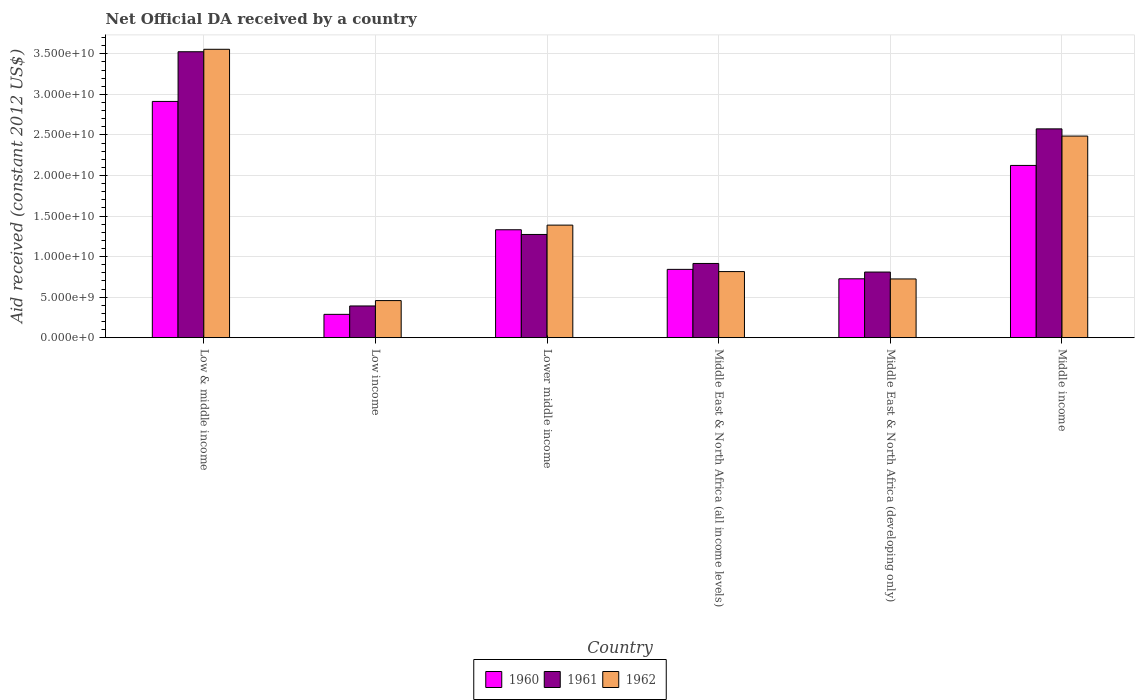What is the label of the 3rd group of bars from the left?
Provide a succinct answer. Lower middle income. What is the net official development assistance aid received in 1961 in Middle East & North Africa (developing only)?
Your answer should be very brief. 8.09e+09. Across all countries, what is the maximum net official development assistance aid received in 1960?
Give a very brief answer. 2.91e+1. Across all countries, what is the minimum net official development assistance aid received in 1962?
Give a very brief answer. 4.57e+09. What is the total net official development assistance aid received in 1962 in the graph?
Keep it short and to the point. 9.43e+1. What is the difference between the net official development assistance aid received in 1961 in Lower middle income and that in Middle income?
Make the answer very short. -1.30e+1. What is the difference between the net official development assistance aid received in 1961 in Middle income and the net official development assistance aid received in 1962 in Low & middle income?
Offer a terse response. -9.81e+09. What is the average net official development assistance aid received in 1961 per country?
Your response must be concise. 1.58e+1. What is the difference between the net official development assistance aid received of/in 1961 and net official development assistance aid received of/in 1960 in Low & middle income?
Ensure brevity in your answer.  6.13e+09. In how many countries, is the net official development assistance aid received in 1960 greater than 8000000000 US$?
Provide a succinct answer. 4. What is the ratio of the net official development assistance aid received in 1960 in Middle East & North Africa (all income levels) to that in Middle income?
Your answer should be very brief. 0.4. Is the net official development assistance aid received in 1961 in Lower middle income less than that in Middle East & North Africa (developing only)?
Offer a very short reply. No. What is the difference between the highest and the second highest net official development assistance aid received in 1961?
Your answer should be very brief. 2.25e+1. What is the difference between the highest and the lowest net official development assistance aid received in 1960?
Your answer should be compact. 2.63e+1. What does the 1st bar from the left in Lower middle income represents?
Ensure brevity in your answer.  1960. What does the 2nd bar from the right in Middle East & North Africa (all income levels) represents?
Offer a terse response. 1961. How many bars are there?
Offer a terse response. 18. What is the difference between two consecutive major ticks on the Y-axis?
Your response must be concise. 5.00e+09. Does the graph contain any zero values?
Give a very brief answer. No. How are the legend labels stacked?
Ensure brevity in your answer.  Horizontal. What is the title of the graph?
Keep it short and to the point. Net Official DA received by a country. What is the label or title of the X-axis?
Offer a very short reply. Country. What is the label or title of the Y-axis?
Keep it short and to the point. Aid received (constant 2012 US$). What is the Aid received (constant 2012 US$) in 1960 in Low & middle income?
Offer a terse response. 2.91e+1. What is the Aid received (constant 2012 US$) in 1961 in Low & middle income?
Provide a succinct answer. 3.53e+1. What is the Aid received (constant 2012 US$) in 1962 in Low & middle income?
Your answer should be very brief. 3.56e+1. What is the Aid received (constant 2012 US$) of 1960 in Low income?
Offer a very short reply. 2.87e+09. What is the Aid received (constant 2012 US$) in 1961 in Low income?
Your answer should be compact. 3.91e+09. What is the Aid received (constant 2012 US$) of 1962 in Low income?
Provide a short and direct response. 4.57e+09. What is the Aid received (constant 2012 US$) in 1960 in Lower middle income?
Provide a succinct answer. 1.33e+1. What is the Aid received (constant 2012 US$) in 1961 in Lower middle income?
Give a very brief answer. 1.27e+1. What is the Aid received (constant 2012 US$) in 1962 in Lower middle income?
Offer a terse response. 1.39e+1. What is the Aid received (constant 2012 US$) in 1960 in Middle East & North Africa (all income levels)?
Offer a terse response. 8.42e+09. What is the Aid received (constant 2012 US$) of 1961 in Middle East & North Africa (all income levels)?
Your response must be concise. 9.15e+09. What is the Aid received (constant 2012 US$) in 1962 in Middle East & North Africa (all income levels)?
Your response must be concise. 8.15e+09. What is the Aid received (constant 2012 US$) in 1960 in Middle East & North Africa (developing only)?
Your answer should be very brief. 7.26e+09. What is the Aid received (constant 2012 US$) of 1961 in Middle East & North Africa (developing only)?
Keep it short and to the point. 8.09e+09. What is the Aid received (constant 2012 US$) of 1962 in Middle East & North Africa (developing only)?
Your response must be concise. 7.24e+09. What is the Aid received (constant 2012 US$) in 1960 in Middle income?
Provide a short and direct response. 2.12e+1. What is the Aid received (constant 2012 US$) of 1961 in Middle income?
Provide a succinct answer. 2.58e+1. What is the Aid received (constant 2012 US$) of 1962 in Middle income?
Your response must be concise. 2.49e+1. Across all countries, what is the maximum Aid received (constant 2012 US$) of 1960?
Ensure brevity in your answer.  2.91e+1. Across all countries, what is the maximum Aid received (constant 2012 US$) of 1961?
Give a very brief answer. 3.53e+1. Across all countries, what is the maximum Aid received (constant 2012 US$) of 1962?
Provide a short and direct response. 3.56e+1. Across all countries, what is the minimum Aid received (constant 2012 US$) of 1960?
Give a very brief answer. 2.87e+09. Across all countries, what is the minimum Aid received (constant 2012 US$) of 1961?
Provide a short and direct response. 3.91e+09. Across all countries, what is the minimum Aid received (constant 2012 US$) in 1962?
Keep it short and to the point. 4.57e+09. What is the total Aid received (constant 2012 US$) in 1960 in the graph?
Offer a terse response. 8.22e+1. What is the total Aid received (constant 2012 US$) of 1961 in the graph?
Give a very brief answer. 9.49e+1. What is the total Aid received (constant 2012 US$) of 1962 in the graph?
Give a very brief answer. 9.43e+1. What is the difference between the Aid received (constant 2012 US$) of 1960 in Low & middle income and that in Low income?
Keep it short and to the point. 2.63e+1. What is the difference between the Aid received (constant 2012 US$) in 1961 in Low & middle income and that in Low income?
Give a very brief answer. 3.14e+1. What is the difference between the Aid received (constant 2012 US$) in 1962 in Low & middle income and that in Low income?
Keep it short and to the point. 3.10e+1. What is the difference between the Aid received (constant 2012 US$) of 1960 in Low & middle income and that in Lower middle income?
Your response must be concise. 1.58e+1. What is the difference between the Aid received (constant 2012 US$) in 1961 in Low & middle income and that in Lower middle income?
Give a very brief answer. 2.25e+1. What is the difference between the Aid received (constant 2012 US$) of 1962 in Low & middle income and that in Lower middle income?
Provide a short and direct response. 2.17e+1. What is the difference between the Aid received (constant 2012 US$) in 1960 in Low & middle income and that in Middle East & North Africa (all income levels)?
Provide a succinct answer. 2.07e+1. What is the difference between the Aid received (constant 2012 US$) of 1961 in Low & middle income and that in Middle East & North Africa (all income levels)?
Your answer should be very brief. 2.61e+1. What is the difference between the Aid received (constant 2012 US$) of 1962 in Low & middle income and that in Middle East & North Africa (all income levels)?
Your answer should be compact. 2.74e+1. What is the difference between the Aid received (constant 2012 US$) of 1960 in Low & middle income and that in Middle East & North Africa (developing only)?
Offer a very short reply. 2.19e+1. What is the difference between the Aid received (constant 2012 US$) of 1961 in Low & middle income and that in Middle East & North Africa (developing only)?
Keep it short and to the point. 2.72e+1. What is the difference between the Aid received (constant 2012 US$) in 1962 in Low & middle income and that in Middle East & North Africa (developing only)?
Offer a terse response. 2.83e+1. What is the difference between the Aid received (constant 2012 US$) of 1960 in Low & middle income and that in Middle income?
Provide a short and direct response. 7.89e+09. What is the difference between the Aid received (constant 2012 US$) of 1961 in Low & middle income and that in Middle income?
Offer a very short reply. 9.51e+09. What is the difference between the Aid received (constant 2012 US$) of 1962 in Low & middle income and that in Middle income?
Provide a succinct answer. 1.07e+1. What is the difference between the Aid received (constant 2012 US$) in 1960 in Low income and that in Lower middle income?
Give a very brief answer. -1.04e+1. What is the difference between the Aid received (constant 2012 US$) of 1961 in Low income and that in Lower middle income?
Your answer should be very brief. -8.82e+09. What is the difference between the Aid received (constant 2012 US$) in 1962 in Low income and that in Lower middle income?
Keep it short and to the point. -9.31e+09. What is the difference between the Aid received (constant 2012 US$) of 1960 in Low income and that in Middle East & North Africa (all income levels)?
Give a very brief answer. -5.55e+09. What is the difference between the Aid received (constant 2012 US$) of 1961 in Low income and that in Middle East & North Africa (all income levels)?
Keep it short and to the point. -5.24e+09. What is the difference between the Aid received (constant 2012 US$) of 1962 in Low income and that in Middle East & North Africa (all income levels)?
Give a very brief answer. -3.58e+09. What is the difference between the Aid received (constant 2012 US$) of 1960 in Low income and that in Middle East & North Africa (developing only)?
Ensure brevity in your answer.  -4.39e+09. What is the difference between the Aid received (constant 2012 US$) in 1961 in Low income and that in Middle East & North Africa (developing only)?
Provide a succinct answer. -4.18e+09. What is the difference between the Aid received (constant 2012 US$) of 1962 in Low income and that in Middle East & North Africa (developing only)?
Your answer should be very brief. -2.67e+09. What is the difference between the Aid received (constant 2012 US$) in 1960 in Low income and that in Middle income?
Give a very brief answer. -1.84e+1. What is the difference between the Aid received (constant 2012 US$) in 1961 in Low income and that in Middle income?
Provide a short and direct response. -2.18e+1. What is the difference between the Aid received (constant 2012 US$) in 1962 in Low income and that in Middle income?
Give a very brief answer. -2.03e+1. What is the difference between the Aid received (constant 2012 US$) in 1960 in Lower middle income and that in Middle East & North Africa (all income levels)?
Your answer should be compact. 4.89e+09. What is the difference between the Aid received (constant 2012 US$) of 1961 in Lower middle income and that in Middle East & North Africa (all income levels)?
Your answer should be very brief. 3.58e+09. What is the difference between the Aid received (constant 2012 US$) of 1962 in Lower middle income and that in Middle East & North Africa (all income levels)?
Keep it short and to the point. 5.73e+09. What is the difference between the Aid received (constant 2012 US$) in 1960 in Lower middle income and that in Middle East & North Africa (developing only)?
Your response must be concise. 6.05e+09. What is the difference between the Aid received (constant 2012 US$) in 1961 in Lower middle income and that in Middle East & North Africa (developing only)?
Give a very brief answer. 4.64e+09. What is the difference between the Aid received (constant 2012 US$) in 1962 in Lower middle income and that in Middle East & North Africa (developing only)?
Offer a very short reply. 6.64e+09. What is the difference between the Aid received (constant 2012 US$) in 1960 in Lower middle income and that in Middle income?
Your answer should be compact. -7.93e+09. What is the difference between the Aid received (constant 2012 US$) in 1961 in Lower middle income and that in Middle income?
Give a very brief answer. -1.30e+1. What is the difference between the Aid received (constant 2012 US$) in 1962 in Lower middle income and that in Middle income?
Your answer should be compact. -1.10e+1. What is the difference between the Aid received (constant 2012 US$) in 1960 in Middle East & North Africa (all income levels) and that in Middle East & North Africa (developing only)?
Keep it short and to the point. 1.16e+09. What is the difference between the Aid received (constant 2012 US$) in 1961 in Middle East & North Africa (all income levels) and that in Middle East & North Africa (developing only)?
Keep it short and to the point. 1.06e+09. What is the difference between the Aid received (constant 2012 US$) of 1962 in Middle East & North Africa (all income levels) and that in Middle East & North Africa (developing only)?
Offer a very short reply. 9.07e+08. What is the difference between the Aid received (constant 2012 US$) of 1960 in Middle East & North Africa (all income levels) and that in Middle income?
Keep it short and to the point. -1.28e+1. What is the difference between the Aid received (constant 2012 US$) of 1961 in Middle East & North Africa (all income levels) and that in Middle income?
Ensure brevity in your answer.  -1.66e+1. What is the difference between the Aid received (constant 2012 US$) of 1962 in Middle East & North Africa (all income levels) and that in Middle income?
Keep it short and to the point. -1.67e+1. What is the difference between the Aid received (constant 2012 US$) in 1960 in Middle East & North Africa (developing only) and that in Middle income?
Keep it short and to the point. -1.40e+1. What is the difference between the Aid received (constant 2012 US$) of 1961 in Middle East & North Africa (developing only) and that in Middle income?
Your answer should be compact. -1.77e+1. What is the difference between the Aid received (constant 2012 US$) in 1962 in Middle East & North Africa (developing only) and that in Middle income?
Keep it short and to the point. -1.76e+1. What is the difference between the Aid received (constant 2012 US$) in 1960 in Low & middle income and the Aid received (constant 2012 US$) in 1961 in Low income?
Give a very brief answer. 2.52e+1. What is the difference between the Aid received (constant 2012 US$) of 1960 in Low & middle income and the Aid received (constant 2012 US$) of 1962 in Low income?
Give a very brief answer. 2.46e+1. What is the difference between the Aid received (constant 2012 US$) in 1961 in Low & middle income and the Aid received (constant 2012 US$) in 1962 in Low income?
Offer a very short reply. 3.07e+1. What is the difference between the Aid received (constant 2012 US$) of 1960 in Low & middle income and the Aid received (constant 2012 US$) of 1961 in Lower middle income?
Ensure brevity in your answer.  1.64e+1. What is the difference between the Aid received (constant 2012 US$) of 1960 in Low & middle income and the Aid received (constant 2012 US$) of 1962 in Lower middle income?
Give a very brief answer. 1.53e+1. What is the difference between the Aid received (constant 2012 US$) in 1961 in Low & middle income and the Aid received (constant 2012 US$) in 1962 in Lower middle income?
Provide a short and direct response. 2.14e+1. What is the difference between the Aid received (constant 2012 US$) of 1960 in Low & middle income and the Aid received (constant 2012 US$) of 1961 in Middle East & North Africa (all income levels)?
Your response must be concise. 2.00e+1. What is the difference between the Aid received (constant 2012 US$) in 1960 in Low & middle income and the Aid received (constant 2012 US$) in 1962 in Middle East & North Africa (all income levels)?
Your answer should be very brief. 2.10e+1. What is the difference between the Aid received (constant 2012 US$) of 1961 in Low & middle income and the Aid received (constant 2012 US$) of 1962 in Middle East & North Africa (all income levels)?
Make the answer very short. 2.71e+1. What is the difference between the Aid received (constant 2012 US$) in 1960 in Low & middle income and the Aid received (constant 2012 US$) in 1961 in Middle East & North Africa (developing only)?
Ensure brevity in your answer.  2.10e+1. What is the difference between the Aid received (constant 2012 US$) of 1960 in Low & middle income and the Aid received (constant 2012 US$) of 1962 in Middle East & North Africa (developing only)?
Your answer should be very brief. 2.19e+1. What is the difference between the Aid received (constant 2012 US$) in 1961 in Low & middle income and the Aid received (constant 2012 US$) in 1962 in Middle East & North Africa (developing only)?
Give a very brief answer. 2.80e+1. What is the difference between the Aid received (constant 2012 US$) of 1960 in Low & middle income and the Aid received (constant 2012 US$) of 1961 in Middle income?
Keep it short and to the point. 3.38e+09. What is the difference between the Aid received (constant 2012 US$) of 1960 in Low & middle income and the Aid received (constant 2012 US$) of 1962 in Middle income?
Make the answer very short. 4.27e+09. What is the difference between the Aid received (constant 2012 US$) of 1961 in Low & middle income and the Aid received (constant 2012 US$) of 1962 in Middle income?
Ensure brevity in your answer.  1.04e+1. What is the difference between the Aid received (constant 2012 US$) of 1960 in Low income and the Aid received (constant 2012 US$) of 1961 in Lower middle income?
Make the answer very short. -9.85e+09. What is the difference between the Aid received (constant 2012 US$) of 1960 in Low income and the Aid received (constant 2012 US$) of 1962 in Lower middle income?
Ensure brevity in your answer.  -1.10e+1. What is the difference between the Aid received (constant 2012 US$) in 1961 in Low income and the Aid received (constant 2012 US$) in 1962 in Lower middle income?
Your answer should be compact. -9.97e+09. What is the difference between the Aid received (constant 2012 US$) of 1960 in Low income and the Aid received (constant 2012 US$) of 1961 in Middle East & North Africa (all income levels)?
Keep it short and to the point. -6.28e+09. What is the difference between the Aid received (constant 2012 US$) in 1960 in Low income and the Aid received (constant 2012 US$) in 1962 in Middle East & North Africa (all income levels)?
Provide a succinct answer. -5.27e+09. What is the difference between the Aid received (constant 2012 US$) in 1961 in Low income and the Aid received (constant 2012 US$) in 1962 in Middle East & North Africa (all income levels)?
Ensure brevity in your answer.  -4.24e+09. What is the difference between the Aid received (constant 2012 US$) of 1960 in Low income and the Aid received (constant 2012 US$) of 1961 in Middle East & North Africa (developing only)?
Your answer should be compact. -5.22e+09. What is the difference between the Aid received (constant 2012 US$) of 1960 in Low income and the Aid received (constant 2012 US$) of 1962 in Middle East & North Africa (developing only)?
Your response must be concise. -4.37e+09. What is the difference between the Aid received (constant 2012 US$) in 1961 in Low income and the Aid received (constant 2012 US$) in 1962 in Middle East & North Africa (developing only)?
Make the answer very short. -3.33e+09. What is the difference between the Aid received (constant 2012 US$) of 1960 in Low income and the Aid received (constant 2012 US$) of 1961 in Middle income?
Make the answer very short. -2.29e+1. What is the difference between the Aid received (constant 2012 US$) in 1960 in Low income and the Aid received (constant 2012 US$) in 1962 in Middle income?
Provide a succinct answer. -2.20e+1. What is the difference between the Aid received (constant 2012 US$) of 1961 in Low income and the Aid received (constant 2012 US$) of 1962 in Middle income?
Offer a very short reply. -2.10e+1. What is the difference between the Aid received (constant 2012 US$) in 1960 in Lower middle income and the Aid received (constant 2012 US$) in 1961 in Middle East & North Africa (all income levels)?
Provide a succinct answer. 4.16e+09. What is the difference between the Aid received (constant 2012 US$) in 1960 in Lower middle income and the Aid received (constant 2012 US$) in 1962 in Middle East & North Africa (all income levels)?
Provide a succinct answer. 5.16e+09. What is the difference between the Aid received (constant 2012 US$) of 1961 in Lower middle income and the Aid received (constant 2012 US$) of 1962 in Middle East & North Africa (all income levels)?
Your answer should be compact. 4.58e+09. What is the difference between the Aid received (constant 2012 US$) in 1960 in Lower middle income and the Aid received (constant 2012 US$) in 1961 in Middle East & North Africa (developing only)?
Offer a very short reply. 5.22e+09. What is the difference between the Aid received (constant 2012 US$) of 1960 in Lower middle income and the Aid received (constant 2012 US$) of 1962 in Middle East & North Africa (developing only)?
Offer a terse response. 6.07e+09. What is the difference between the Aid received (constant 2012 US$) in 1961 in Lower middle income and the Aid received (constant 2012 US$) in 1962 in Middle East & North Africa (developing only)?
Offer a terse response. 5.49e+09. What is the difference between the Aid received (constant 2012 US$) of 1960 in Lower middle income and the Aid received (constant 2012 US$) of 1961 in Middle income?
Your response must be concise. -1.24e+1. What is the difference between the Aid received (constant 2012 US$) in 1960 in Lower middle income and the Aid received (constant 2012 US$) in 1962 in Middle income?
Provide a succinct answer. -1.16e+1. What is the difference between the Aid received (constant 2012 US$) of 1961 in Lower middle income and the Aid received (constant 2012 US$) of 1962 in Middle income?
Your answer should be compact. -1.21e+1. What is the difference between the Aid received (constant 2012 US$) of 1960 in Middle East & North Africa (all income levels) and the Aid received (constant 2012 US$) of 1961 in Middle East & North Africa (developing only)?
Your answer should be compact. 3.30e+08. What is the difference between the Aid received (constant 2012 US$) in 1960 in Middle East & North Africa (all income levels) and the Aid received (constant 2012 US$) in 1962 in Middle East & North Africa (developing only)?
Give a very brief answer. 1.18e+09. What is the difference between the Aid received (constant 2012 US$) in 1961 in Middle East & North Africa (all income levels) and the Aid received (constant 2012 US$) in 1962 in Middle East & North Africa (developing only)?
Ensure brevity in your answer.  1.91e+09. What is the difference between the Aid received (constant 2012 US$) of 1960 in Middle East & North Africa (all income levels) and the Aid received (constant 2012 US$) of 1961 in Middle income?
Offer a terse response. -1.73e+1. What is the difference between the Aid received (constant 2012 US$) of 1960 in Middle East & North Africa (all income levels) and the Aid received (constant 2012 US$) of 1962 in Middle income?
Your answer should be very brief. -1.64e+1. What is the difference between the Aid received (constant 2012 US$) in 1961 in Middle East & North Africa (all income levels) and the Aid received (constant 2012 US$) in 1962 in Middle income?
Ensure brevity in your answer.  -1.57e+1. What is the difference between the Aid received (constant 2012 US$) in 1960 in Middle East & North Africa (developing only) and the Aid received (constant 2012 US$) in 1961 in Middle income?
Make the answer very short. -1.85e+1. What is the difference between the Aid received (constant 2012 US$) in 1960 in Middle East & North Africa (developing only) and the Aid received (constant 2012 US$) in 1962 in Middle income?
Give a very brief answer. -1.76e+1. What is the difference between the Aid received (constant 2012 US$) in 1961 in Middle East & North Africa (developing only) and the Aid received (constant 2012 US$) in 1962 in Middle income?
Your response must be concise. -1.68e+1. What is the average Aid received (constant 2012 US$) in 1960 per country?
Provide a short and direct response. 1.37e+1. What is the average Aid received (constant 2012 US$) of 1961 per country?
Keep it short and to the point. 1.58e+1. What is the average Aid received (constant 2012 US$) in 1962 per country?
Ensure brevity in your answer.  1.57e+1. What is the difference between the Aid received (constant 2012 US$) of 1960 and Aid received (constant 2012 US$) of 1961 in Low & middle income?
Your answer should be very brief. -6.13e+09. What is the difference between the Aid received (constant 2012 US$) in 1960 and Aid received (constant 2012 US$) in 1962 in Low & middle income?
Ensure brevity in your answer.  -6.43e+09. What is the difference between the Aid received (constant 2012 US$) in 1961 and Aid received (constant 2012 US$) in 1962 in Low & middle income?
Give a very brief answer. -3.02e+08. What is the difference between the Aid received (constant 2012 US$) of 1960 and Aid received (constant 2012 US$) of 1961 in Low income?
Your answer should be very brief. -1.04e+09. What is the difference between the Aid received (constant 2012 US$) in 1960 and Aid received (constant 2012 US$) in 1962 in Low income?
Make the answer very short. -1.70e+09. What is the difference between the Aid received (constant 2012 US$) of 1961 and Aid received (constant 2012 US$) of 1962 in Low income?
Give a very brief answer. -6.62e+08. What is the difference between the Aid received (constant 2012 US$) in 1960 and Aid received (constant 2012 US$) in 1961 in Lower middle income?
Offer a terse response. 5.79e+08. What is the difference between the Aid received (constant 2012 US$) of 1960 and Aid received (constant 2012 US$) of 1962 in Lower middle income?
Keep it short and to the point. -5.73e+08. What is the difference between the Aid received (constant 2012 US$) in 1961 and Aid received (constant 2012 US$) in 1962 in Lower middle income?
Your answer should be compact. -1.15e+09. What is the difference between the Aid received (constant 2012 US$) in 1960 and Aid received (constant 2012 US$) in 1961 in Middle East & North Africa (all income levels)?
Keep it short and to the point. -7.30e+08. What is the difference between the Aid received (constant 2012 US$) in 1960 and Aid received (constant 2012 US$) in 1962 in Middle East & North Africa (all income levels)?
Offer a very short reply. 2.73e+08. What is the difference between the Aid received (constant 2012 US$) of 1961 and Aid received (constant 2012 US$) of 1962 in Middle East & North Africa (all income levels)?
Make the answer very short. 1.00e+09. What is the difference between the Aid received (constant 2012 US$) in 1960 and Aid received (constant 2012 US$) in 1961 in Middle East & North Africa (developing only)?
Your answer should be very brief. -8.32e+08. What is the difference between the Aid received (constant 2012 US$) of 1960 and Aid received (constant 2012 US$) of 1962 in Middle East & North Africa (developing only)?
Give a very brief answer. 1.81e+07. What is the difference between the Aid received (constant 2012 US$) of 1961 and Aid received (constant 2012 US$) of 1962 in Middle East & North Africa (developing only)?
Provide a succinct answer. 8.50e+08. What is the difference between the Aid received (constant 2012 US$) of 1960 and Aid received (constant 2012 US$) of 1961 in Middle income?
Provide a short and direct response. -4.51e+09. What is the difference between the Aid received (constant 2012 US$) of 1960 and Aid received (constant 2012 US$) of 1962 in Middle income?
Ensure brevity in your answer.  -3.62e+09. What is the difference between the Aid received (constant 2012 US$) in 1961 and Aid received (constant 2012 US$) in 1962 in Middle income?
Provide a succinct answer. 8.89e+08. What is the ratio of the Aid received (constant 2012 US$) in 1960 in Low & middle income to that in Low income?
Provide a succinct answer. 10.13. What is the ratio of the Aid received (constant 2012 US$) of 1961 in Low & middle income to that in Low income?
Provide a succinct answer. 9.02. What is the ratio of the Aid received (constant 2012 US$) in 1962 in Low & middle income to that in Low income?
Your response must be concise. 7.78. What is the ratio of the Aid received (constant 2012 US$) of 1960 in Low & middle income to that in Lower middle income?
Your response must be concise. 2.19. What is the ratio of the Aid received (constant 2012 US$) in 1961 in Low & middle income to that in Lower middle income?
Make the answer very short. 2.77. What is the ratio of the Aid received (constant 2012 US$) of 1962 in Low & middle income to that in Lower middle income?
Ensure brevity in your answer.  2.56. What is the ratio of the Aid received (constant 2012 US$) of 1960 in Low & middle income to that in Middle East & North Africa (all income levels)?
Ensure brevity in your answer.  3.46. What is the ratio of the Aid received (constant 2012 US$) in 1961 in Low & middle income to that in Middle East & North Africa (all income levels)?
Offer a very short reply. 3.85. What is the ratio of the Aid received (constant 2012 US$) of 1962 in Low & middle income to that in Middle East & North Africa (all income levels)?
Your answer should be very brief. 4.36. What is the ratio of the Aid received (constant 2012 US$) of 1960 in Low & middle income to that in Middle East & North Africa (developing only)?
Make the answer very short. 4.01. What is the ratio of the Aid received (constant 2012 US$) of 1961 in Low & middle income to that in Middle East & North Africa (developing only)?
Provide a short and direct response. 4.36. What is the ratio of the Aid received (constant 2012 US$) of 1962 in Low & middle income to that in Middle East & North Africa (developing only)?
Provide a succinct answer. 4.91. What is the ratio of the Aid received (constant 2012 US$) of 1960 in Low & middle income to that in Middle income?
Offer a very short reply. 1.37. What is the ratio of the Aid received (constant 2012 US$) in 1961 in Low & middle income to that in Middle income?
Your response must be concise. 1.37. What is the ratio of the Aid received (constant 2012 US$) of 1962 in Low & middle income to that in Middle income?
Offer a very short reply. 1.43. What is the ratio of the Aid received (constant 2012 US$) in 1960 in Low income to that in Lower middle income?
Provide a succinct answer. 0.22. What is the ratio of the Aid received (constant 2012 US$) in 1961 in Low income to that in Lower middle income?
Make the answer very short. 0.31. What is the ratio of the Aid received (constant 2012 US$) in 1962 in Low income to that in Lower middle income?
Offer a very short reply. 0.33. What is the ratio of the Aid received (constant 2012 US$) of 1960 in Low income to that in Middle East & North Africa (all income levels)?
Offer a terse response. 0.34. What is the ratio of the Aid received (constant 2012 US$) of 1961 in Low income to that in Middle East & North Africa (all income levels)?
Give a very brief answer. 0.43. What is the ratio of the Aid received (constant 2012 US$) of 1962 in Low income to that in Middle East & North Africa (all income levels)?
Make the answer very short. 0.56. What is the ratio of the Aid received (constant 2012 US$) of 1960 in Low income to that in Middle East & North Africa (developing only)?
Provide a short and direct response. 0.4. What is the ratio of the Aid received (constant 2012 US$) of 1961 in Low income to that in Middle East & North Africa (developing only)?
Provide a short and direct response. 0.48. What is the ratio of the Aid received (constant 2012 US$) of 1962 in Low income to that in Middle East & North Africa (developing only)?
Offer a very short reply. 0.63. What is the ratio of the Aid received (constant 2012 US$) in 1960 in Low income to that in Middle income?
Your response must be concise. 0.14. What is the ratio of the Aid received (constant 2012 US$) of 1961 in Low income to that in Middle income?
Your answer should be very brief. 0.15. What is the ratio of the Aid received (constant 2012 US$) in 1962 in Low income to that in Middle income?
Offer a terse response. 0.18. What is the ratio of the Aid received (constant 2012 US$) of 1960 in Lower middle income to that in Middle East & North Africa (all income levels)?
Keep it short and to the point. 1.58. What is the ratio of the Aid received (constant 2012 US$) in 1961 in Lower middle income to that in Middle East & North Africa (all income levels)?
Your answer should be very brief. 1.39. What is the ratio of the Aid received (constant 2012 US$) of 1962 in Lower middle income to that in Middle East & North Africa (all income levels)?
Your answer should be very brief. 1.7. What is the ratio of the Aid received (constant 2012 US$) of 1960 in Lower middle income to that in Middle East & North Africa (developing only)?
Ensure brevity in your answer.  1.83. What is the ratio of the Aid received (constant 2012 US$) in 1961 in Lower middle income to that in Middle East & North Africa (developing only)?
Provide a short and direct response. 1.57. What is the ratio of the Aid received (constant 2012 US$) in 1962 in Lower middle income to that in Middle East & North Africa (developing only)?
Your response must be concise. 1.92. What is the ratio of the Aid received (constant 2012 US$) of 1960 in Lower middle income to that in Middle income?
Make the answer very short. 0.63. What is the ratio of the Aid received (constant 2012 US$) in 1961 in Lower middle income to that in Middle income?
Provide a short and direct response. 0.49. What is the ratio of the Aid received (constant 2012 US$) of 1962 in Lower middle income to that in Middle income?
Your answer should be compact. 0.56. What is the ratio of the Aid received (constant 2012 US$) in 1960 in Middle East & North Africa (all income levels) to that in Middle East & North Africa (developing only)?
Your answer should be compact. 1.16. What is the ratio of the Aid received (constant 2012 US$) in 1961 in Middle East & North Africa (all income levels) to that in Middle East & North Africa (developing only)?
Offer a very short reply. 1.13. What is the ratio of the Aid received (constant 2012 US$) in 1962 in Middle East & North Africa (all income levels) to that in Middle East & North Africa (developing only)?
Your response must be concise. 1.13. What is the ratio of the Aid received (constant 2012 US$) in 1960 in Middle East & North Africa (all income levels) to that in Middle income?
Your response must be concise. 0.4. What is the ratio of the Aid received (constant 2012 US$) of 1961 in Middle East & North Africa (all income levels) to that in Middle income?
Keep it short and to the point. 0.36. What is the ratio of the Aid received (constant 2012 US$) of 1962 in Middle East & North Africa (all income levels) to that in Middle income?
Make the answer very short. 0.33. What is the ratio of the Aid received (constant 2012 US$) in 1960 in Middle East & North Africa (developing only) to that in Middle income?
Give a very brief answer. 0.34. What is the ratio of the Aid received (constant 2012 US$) in 1961 in Middle East & North Africa (developing only) to that in Middle income?
Provide a succinct answer. 0.31. What is the ratio of the Aid received (constant 2012 US$) in 1962 in Middle East & North Africa (developing only) to that in Middle income?
Your answer should be very brief. 0.29. What is the difference between the highest and the second highest Aid received (constant 2012 US$) in 1960?
Your answer should be compact. 7.89e+09. What is the difference between the highest and the second highest Aid received (constant 2012 US$) in 1961?
Offer a terse response. 9.51e+09. What is the difference between the highest and the second highest Aid received (constant 2012 US$) in 1962?
Your answer should be very brief. 1.07e+1. What is the difference between the highest and the lowest Aid received (constant 2012 US$) in 1960?
Your response must be concise. 2.63e+1. What is the difference between the highest and the lowest Aid received (constant 2012 US$) of 1961?
Your answer should be very brief. 3.14e+1. What is the difference between the highest and the lowest Aid received (constant 2012 US$) in 1962?
Keep it short and to the point. 3.10e+1. 